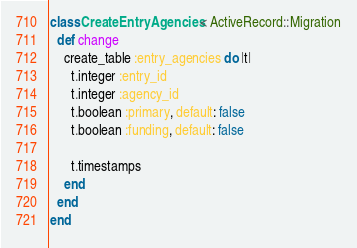Convert code to text. <code><loc_0><loc_0><loc_500><loc_500><_Ruby_>class CreateEntryAgencies < ActiveRecord::Migration
  def change
    create_table :entry_agencies do |t|
      t.integer :entry_id
      t.integer :agency_id
      t.boolean :primary, default: false
      t.boolean :funding, default: false

      t.timestamps
    end
  end
end
</code> 